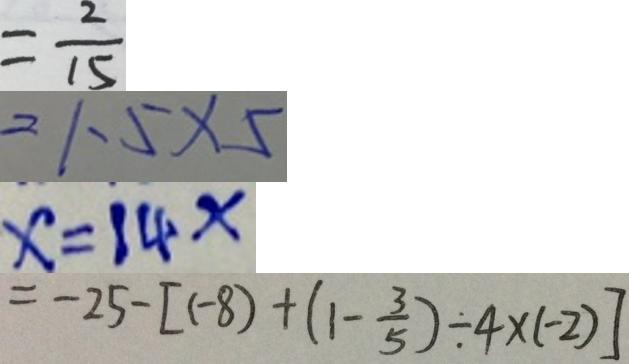Convert formula to latex. <formula><loc_0><loc_0><loc_500><loc_500>= \frac { 2 } { 1 5 } 
 = 1 . 5 \times 5 
 x = 1 4 x 
 = - 2 5 - [ ( - 8 ) + ( 1 - \frac { 3 } { 5 } ) \div 4 \times ( - 2 ) ]</formula> 